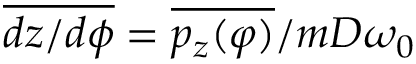<formula> <loc_0><loc_0><loc_500><loc_500>\overline { d z / d \phi } = \overline { { p _ { z } ( \varphi ) } } / m D \omega _ { 0 }</formula> 